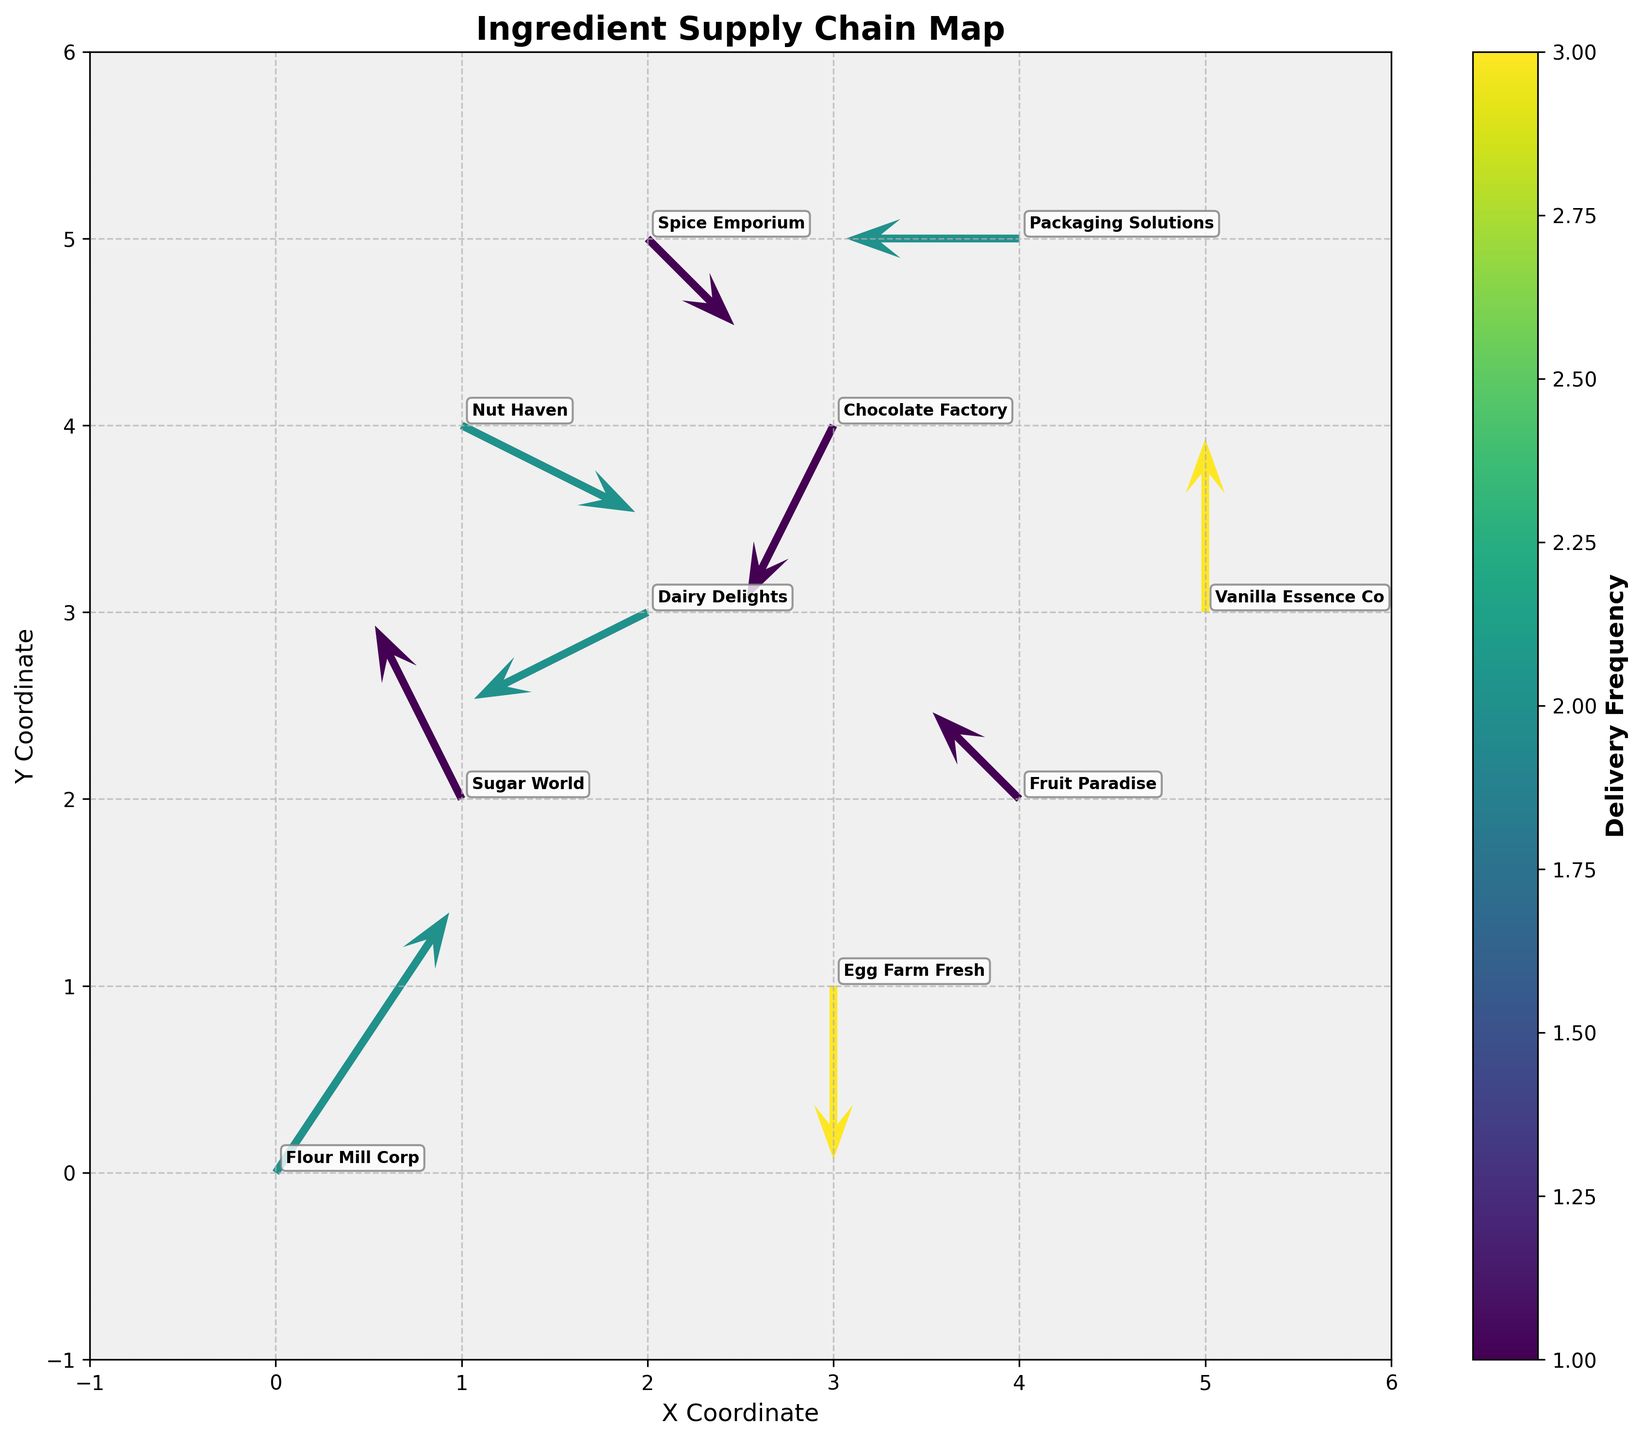what is the title of the figure? The title is usually displayed at the top of the figure. In this plot, the title is "Ingredient Supply Chain Map" which is mentioned at the top.
Answer: Ingredient Supply Chain Map how many suppliers are depicted in the figure? By examining the annotations in the plot, each supplier is labeled next to the quiver arrows. Count the distinct suppliers.
Answer: 10 which supplier has the highest delivery frequency? The delivery frequency can be inferred from the color intensity on the plot. The color bar shows the frequency scale, and the darkest color corresponds to the highest frequency. Identify the supplier with this color.
Answer: Egg Farm Fresh what are the x, y coordinates of Vanilla Essence Co? Locate the label for Vanilla Essence Co on the plot, then note the corresponding x and y coordinates from the plot.
Answer: (5, 3) what is the range of the x and y axes? By looking at the plot’s x and y axis labels and tick marks, we can determine that the axes range from -1 to 6.
Answer: -1 to 6 what is the overall trend in the delivery directions of the suppliers? Examine the direction and length of the arrows (u, v) on the plot. Most arrows seem to be pointing upwards, downwards, or sideways suggesting varied delivery routes without a single dominant direction.
Answer: Varied directions which supplier is closest to the origin (0, 0)? Compare the distances of each supplier from the origin using the Pythagorean theorem: sqrt(x^2 + y^2). The coordinates closest to (0, 0) are for Flour Mill Corp.
Answer: Flour Mill Corp how many suppliers have delivery frequencies of 2? Based on the color represented in the color bar, count the number of suppliers that match the color representing the frequency of 2.
Answer: 5 which delivery route has the longest distance? The lengths of the arrows (u, v) represent delivery routes. Calculate the length using sqrt(u^2 + v^2) and identify the route with the longest vector. The route from Flour Mill Corp has the longest distance.
Answer: Flour Mill Corp what does the color bar in the figure represent? The color bar is located on the side of the plot and indicates what is being measured by the color of the arrows. Here, the color bar represents delivery frequency, as labeled.
Answer: Delivery Frequency 